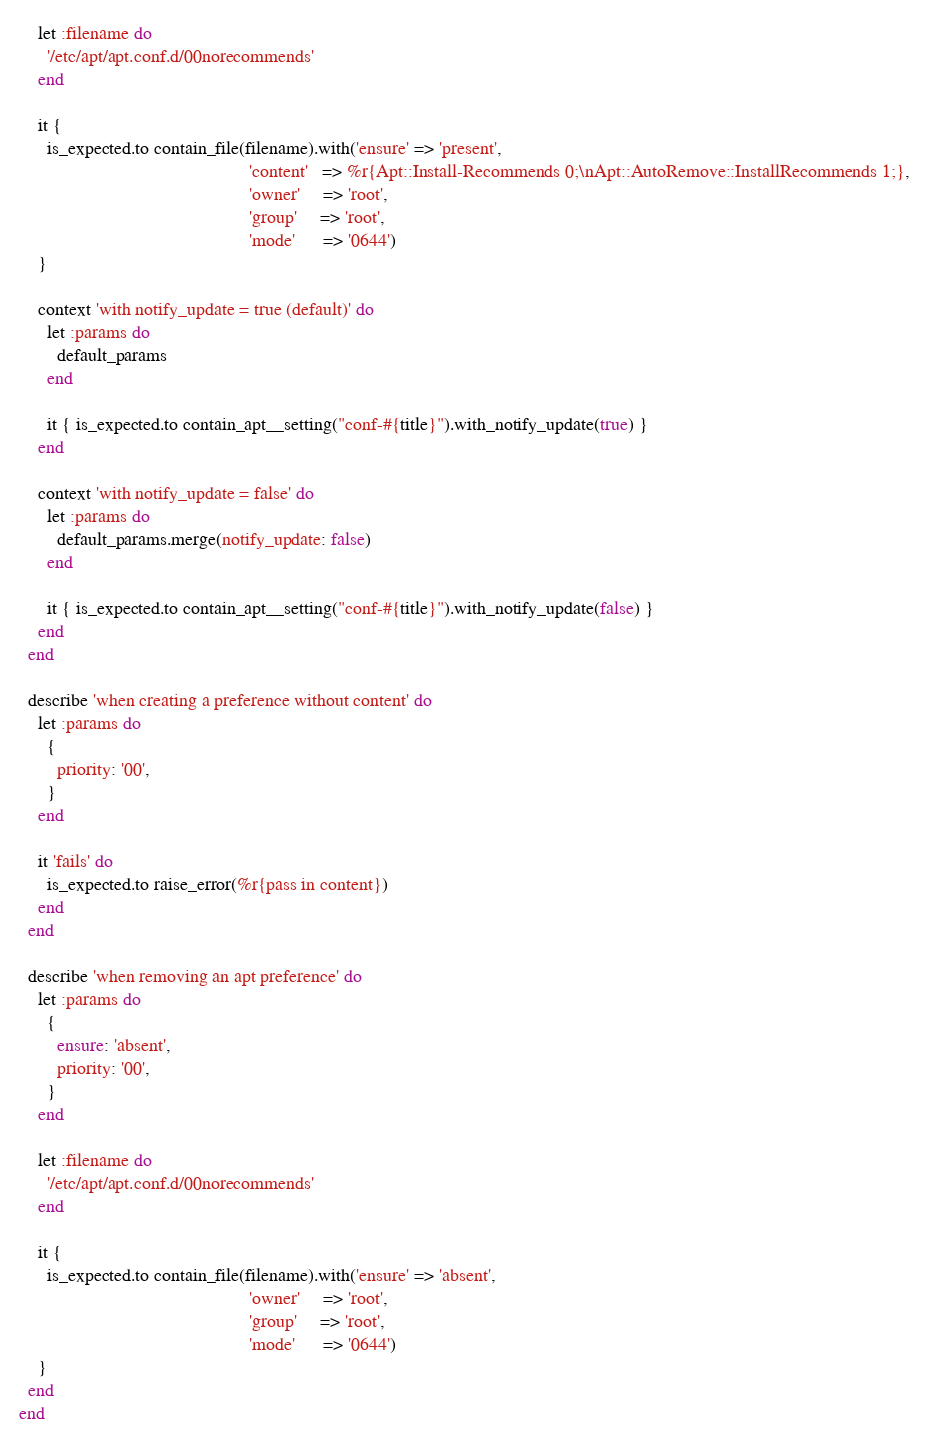Convert code to text. <code><loc_0><loc_0><loc_500><loc_500><_Ruby_>
    let :filename do
      '/etc/apt/apt.conf.d/00norecommends'
    end

    it {
      is_expected.to contain_file(filename).with('ensure' => 'present',
                                                 'content'   => %r{Apt::Install-Recommends 0;\nApt::AutoRemove::InstallRecommends 1;},
                                                 'owner'     => 'root',
                                                 'group'     => 'root',
                                                 'mode'      => '0644')
    }

    context 'with notify_update = true (default)' do
      let :params do
        default_params
      end

      it { is_expected.to contain_apt__setting("conf-#{title}").with_notify_update(true) }
    end

    context 'with notify_update = false' do
      let :params do
        default_params.merge(notify_update: false)
      end

      it { is_expected.to contain_apt__setting("conf-#{title}").with_notify_update(false) }
    end
  end

  describe 'when creating a preference without content' do
    let :params do
      {
        priority: '00',
      }
    end

    it 'fails' do
      is_expected.to raise_error(%r{pass in content})
    end
  end

  describe 'when removing an apt preference' do
    let :params do
      {
        ensure: 'absent',
        priority: '00',
      }
    end

    let :filename do
      '/etc/apt/apt.conf.d/00norecommends'
    end

    it {
      is_expected.to contain_file(filename).with('ensure' => 'absent',
                                                 'owner'     => 'root',
                                                 'group'     => 'root',
                                                 'mode'      => '0644')
    }
  end
end
</code> 